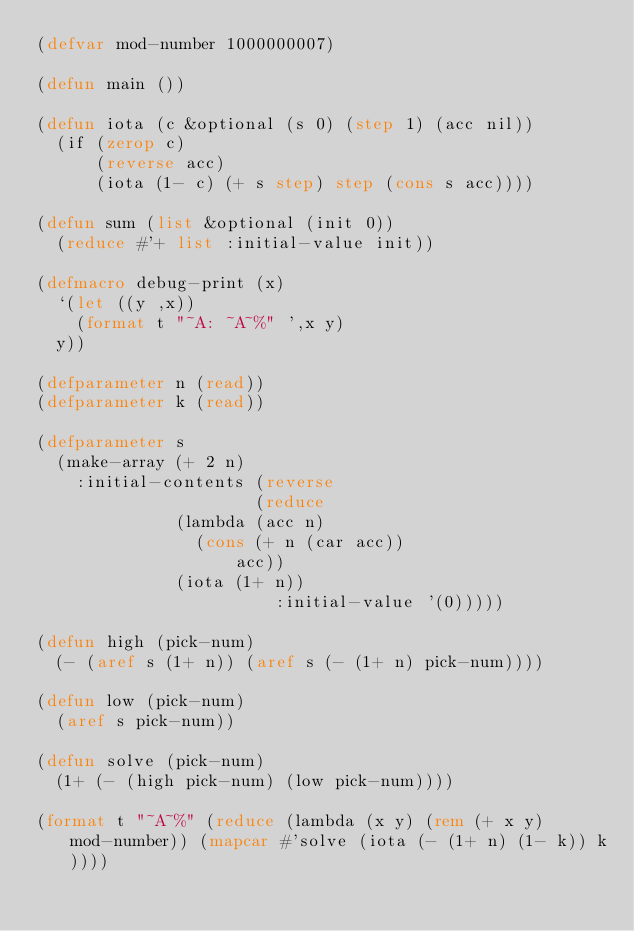Convert code to text. <code><loc_0><loc_0><loc_500><loc_500><_Lisp_>(defvar mod-number 1000000007)

(defun main ())

(defun iota (c &optional (s 0) (step 1) (acc nil))
  (if (zerop c)
      (reverse acc)
      (iota (1- c) (+ s step) step (cons s acc))))

(defun sum (list &optional (init 0))
  (reduce #'+ list :initial-value init))

(defmacro debug-print (x)
  `(let ((y ,x))
    (format t "~A: ~A~%" ',x y)
	y))

(defparameter n (read))
(defparameter k (read))

(defparameter s
  (make-array (+ 2 n)
    :initial-contents (reverse
	                    (reduce
						  (lambda (acc n)
						    (cons (+ n (car acc))
							      acc))
						  (iota (1+ n))
	                      :initial-value '(0)))))

(defun high (pick-num)
  (- (aref s (1+ n)) (aref s (- (1+ n) pick-num))))

(defun low (pick-num)
  (aref s pick-num))

(defun solve (pick-num)
  (1+ (- (high pick-num) (low pick-num))))

(format t "~A~%" (reduce (lambda (x y) (rem (+ x y) mod-number)) (mapcar #'solve (iota (- (1+ n) (1- k)) k))))</code> 